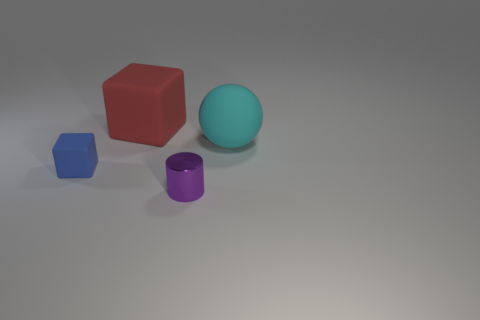There is a large thing that is the same material as the big red block; what shape is it?
Your answer should be very brief. Sphere. What size is the block behind the object to the left of the cube behind the big cyan ball?
Offer a terse response. Large. Is the number of blue rubber blocks greater than the number of large metallic spheres?
Offer a very short reply. Yes. Do the matte thing that is behind the cyan thing and the rubber thing in front of the large ball have the same color?
Your response must be concise. No. Do the small object in front of the blue matte cube and the tiny object left of the large red rubber thing have the same material?
Your response must be concise. No. What number of other rubber spheres are the same size as the matte ball?
Ensure brevity in your answer.  0. Is the number of big things less than the number of large gray spheres?
Your answer should be compact. No. What shape is the matte object on the right side of the thing in front of the small matte cube?
Keep it short and to the point. Sphere. There is a cyan object that is the same size as the red object; what shape is it?
Provide a succinct answer. Sphere. Are there any other red objects that have the same shape as the large red object?
Keep it short and to the point. No. 